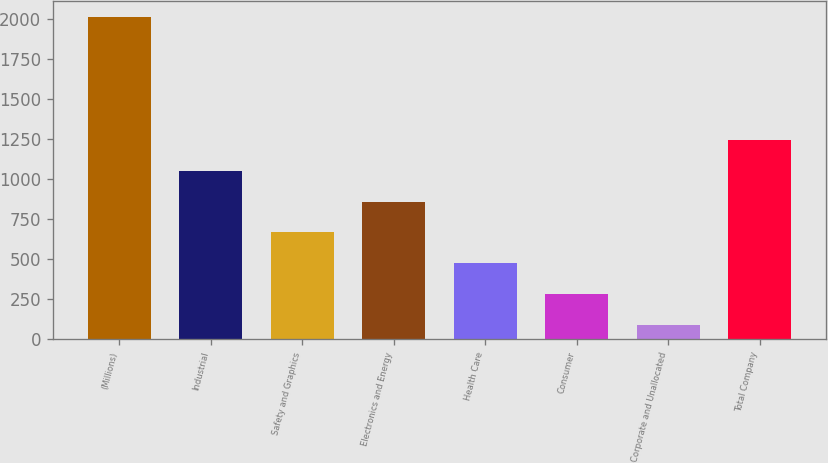Convert chart to OTSL. <chart><loc_0><loc_0><loc_500><loc_500><bar_chart><fcel>(Millions)<fcel>Industrial<fcel>Safety and Graphics<fcel>Electronics and Energy<fcel>Health Care<fcel>Consumer<fcel>Corporate and Unallocated<fcel>Total Company<nl><fcel>2011<fcel>1051.5<fcel>667.7<fcel>859.6<fcel>475.8<fcel>283.9<fcel>92<fcel>1243.4<nl></chart> 